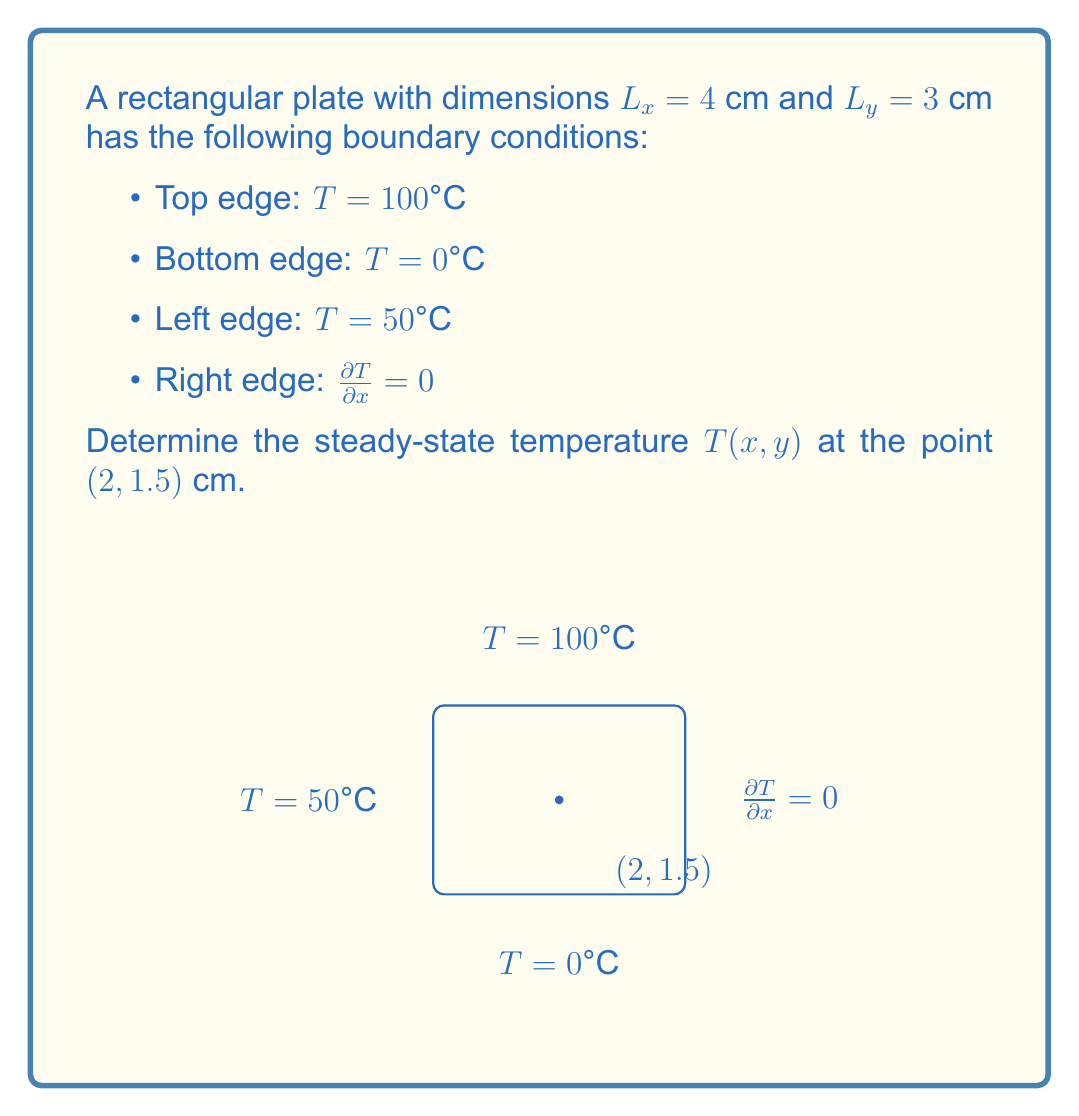What is the answer to this math problem? To solve this problem, we'll use the separation of variables method for the 2D heat equation:

1) The general solution for the temperature distribution is:
   $$T(x,y) = \sum_{n=1}^{\infty} (A_n \cosh(\lambda_n x) + B_n \sinh(\lambda_n x)) \sin(\lambda_n y)$$
   where $\lambda_n = \frac{n\pi}{L_y}$

2) Apply the boundary conditions:
   a) At $y = 0$: $T(x,0) = 0$ (already satisfied by the general solution)
   b) At $y = L_y = 3$: $T(x,3) = 100$
   c) At $x = 0$: $T(0,y) = 50$
   d) At $x = L_x = 4$: $\frac{\partial T}{\partial x}(4,y) = 0$

3) From condition (d), we get:
   $$A_n \sinh(4\lambda_n) + B_n \cosh(4\lambda_n) = 0$$

4) From conditions (b) and (c), we can determine the coefficients:
   $$A_n = \frac{200}{\pi n} \frac{\sinh(4\lambda_n)}{\sinh(4\lambda_n)^2 + \sin^2(n\pi)}$$
   $$B_n = -A_n \tanh(4\lambda_n)$$

5) The temperature distribution is then:
   $$T(x,y) = 50 + 50\frac{y}{3} + \sum_{n=1}^{\infty} A_n (\cosh(\lambda_n x) - \tanh(4\lambda_n) \sinh(\lambda_n x)) \sin(\lambda_n y)$$

6) At the point (2, 1.5):
   $$T(2,1.5) = 50 + 25 + \sum_{n=1}^{\infty} A_n (\cosh(2\lambda_n) - \tanh(4\lambda_n) \sinh(2\lambda_n)) \sin(0.5n\pi)$$

7) Calculate the sum numerically, considering the first few terms (e.g., n = 1 to 5) for a good approximation.
Answer: $T(2,1.5) \approx 78.2°C$ 